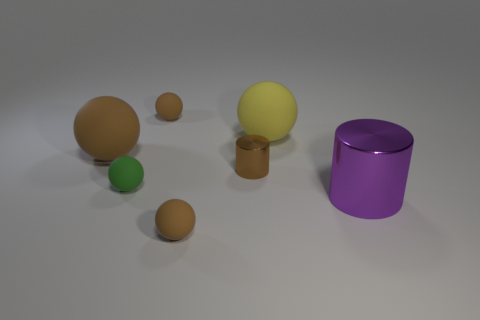Subtract all brown balls. How many were subtracted if there are1brown balls left? 2 Subtract all big balls. How many balls are left? 3 Subtract all green spheres. How many spheres are left? 4 Subtract all balls. How many objects are left? 2 Subtract 1 spheres. How many spheres are left? 4 Subtract all gray spheres. How many blue cylinders are left? 0 Add 6 yellow rubber objects. How many yellow rubber objects are left? 7 Add 6 small gray matte cubes. How many small gray matte cubes exist? 6 Add 2 matte spheres. How many objects exist? 9 Subtract 0 red spheres. How many objects are left? 7 